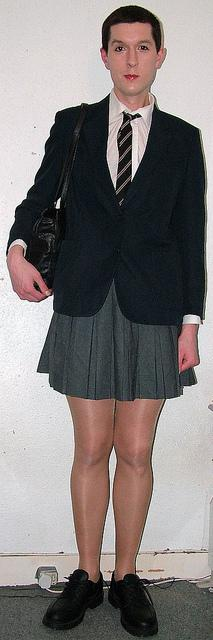What kind of uniform is worn by the man in this picture? Please explain your reasoning. school. The uniform is for school. 